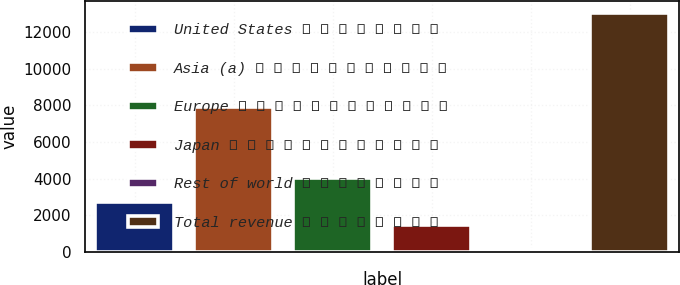Convert chart to OTSL. <chart><loc_0><loc_0><loc_500><loc_500><bar_chart><fcel>United States � � � � � � � �<fcel>Asia (a) � � � � � � � � � � �<fcel>Europe � � � � � � � � � � � �<fcel>Japan � � � � � � � � � � � �<fcel>Rest of world � � � � � � � �<fcel>Total revenue � � � � � � � �<nl><fcel>2753<fcel>7915<fcel>4039.5<fcel>1466.5<fcel>180<fcel>13045<nl></chart> 